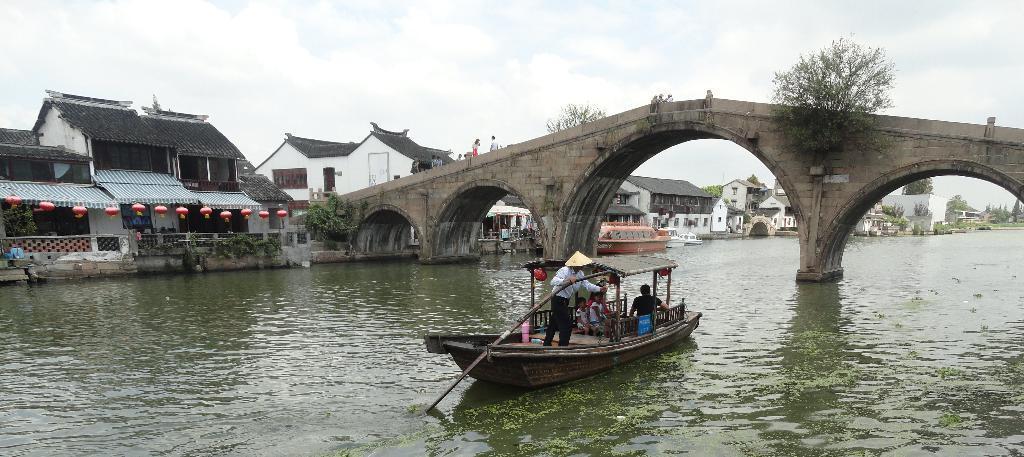In one or two sentences, can you explain what this image depicts? In this image there are some persons sitting on the boat as we can see on the bottom of this image and there is a lake on the bottom of this image, and there is a bridge in middle of this image and there are some buildings in the background. There are some persons standing on the bridge as we can see in middle of this image and there is a sky at top of this image. 